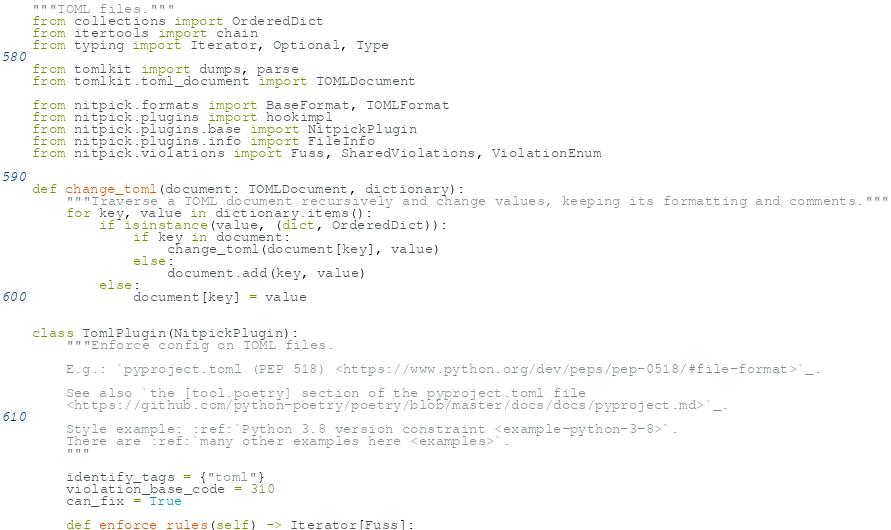<code> <loc_0><loc_0><loc_500><loc_500><_Python_>"""TOML files."""
from collections import OrderedDict
from itertools import chain
from typing import Iterator, Optional, Type

from tomlkit import dumps, parse
from tomlkit.toml_document import TOMLDocument

from nitpick.formats import BaseFormat, TOMLFormat
from nitpick.plugins import hookimpl
from nitpick.plugins.base import NitpickPlugin
from nitpick.plugins.info import FileInfo
from nitpick.violations import Fuss, SharedViolations, ViolationEnum


def change_toml(document: TOMLDocument, dictionary):
    """Traverse a TOML document recursively and change values, keeping its formatting and comments."""
    for key, value in dictionary.items():
        if isinstance(value, (dict, OrderedDict)):
            if key in document:
                change_toml(document[key], value)
            else:
                document.add(key, value)
        else:
            document[key] = value


class TomlPlugin(NitpickPlugin):
    """Enforce config on TOML files.

    E.g.: `pyproject.toml (PEP 518) <https://www.python.org/dev/peps/pep-0518/#file-format>`_.

    See also `the [tool.poetry] section of the pyproject.toml file
    <https://github.com/python-poetry/poetry/blob/master/docs/docs/pyproject.md>`_.

    Style example: :ref:`Python 3.8 version constraint <example-python-3-8>`.
    There are :ref:`many other examples here <examples>`.
    """

    identify_tags = {"toml"}
    violation_base_code = 310
    can_fix = True

    def enforce_rules(self) -> Iterator[Fuss]:</code> 